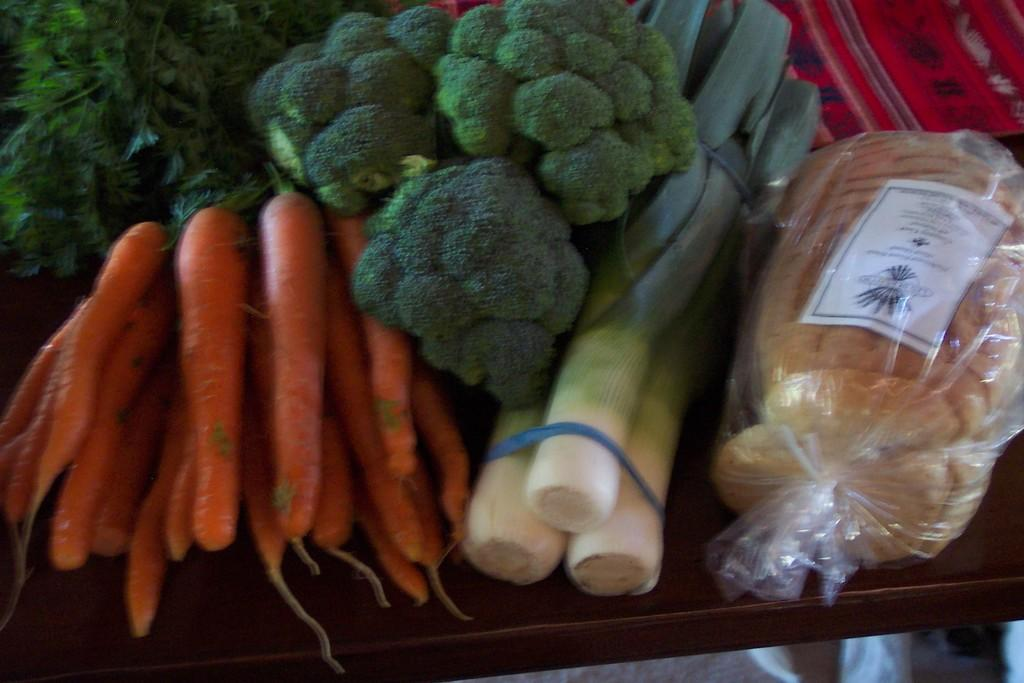What type of food items can be seen in the image? There are vegetables and pieces of bread in the image. How are the vegetables and bread arranged in the image? The vegetables and bread are placed in a cover. Where is the cover with the vegetables and bread located? The cover is placed on a table. Can you see any blood or tiger in the image? No, there is no blood or tiger present in the image. How can we help the vegetables and bread in the image? The vegetables and bread do not require help, as they are simply being stored in a cover on a table. 